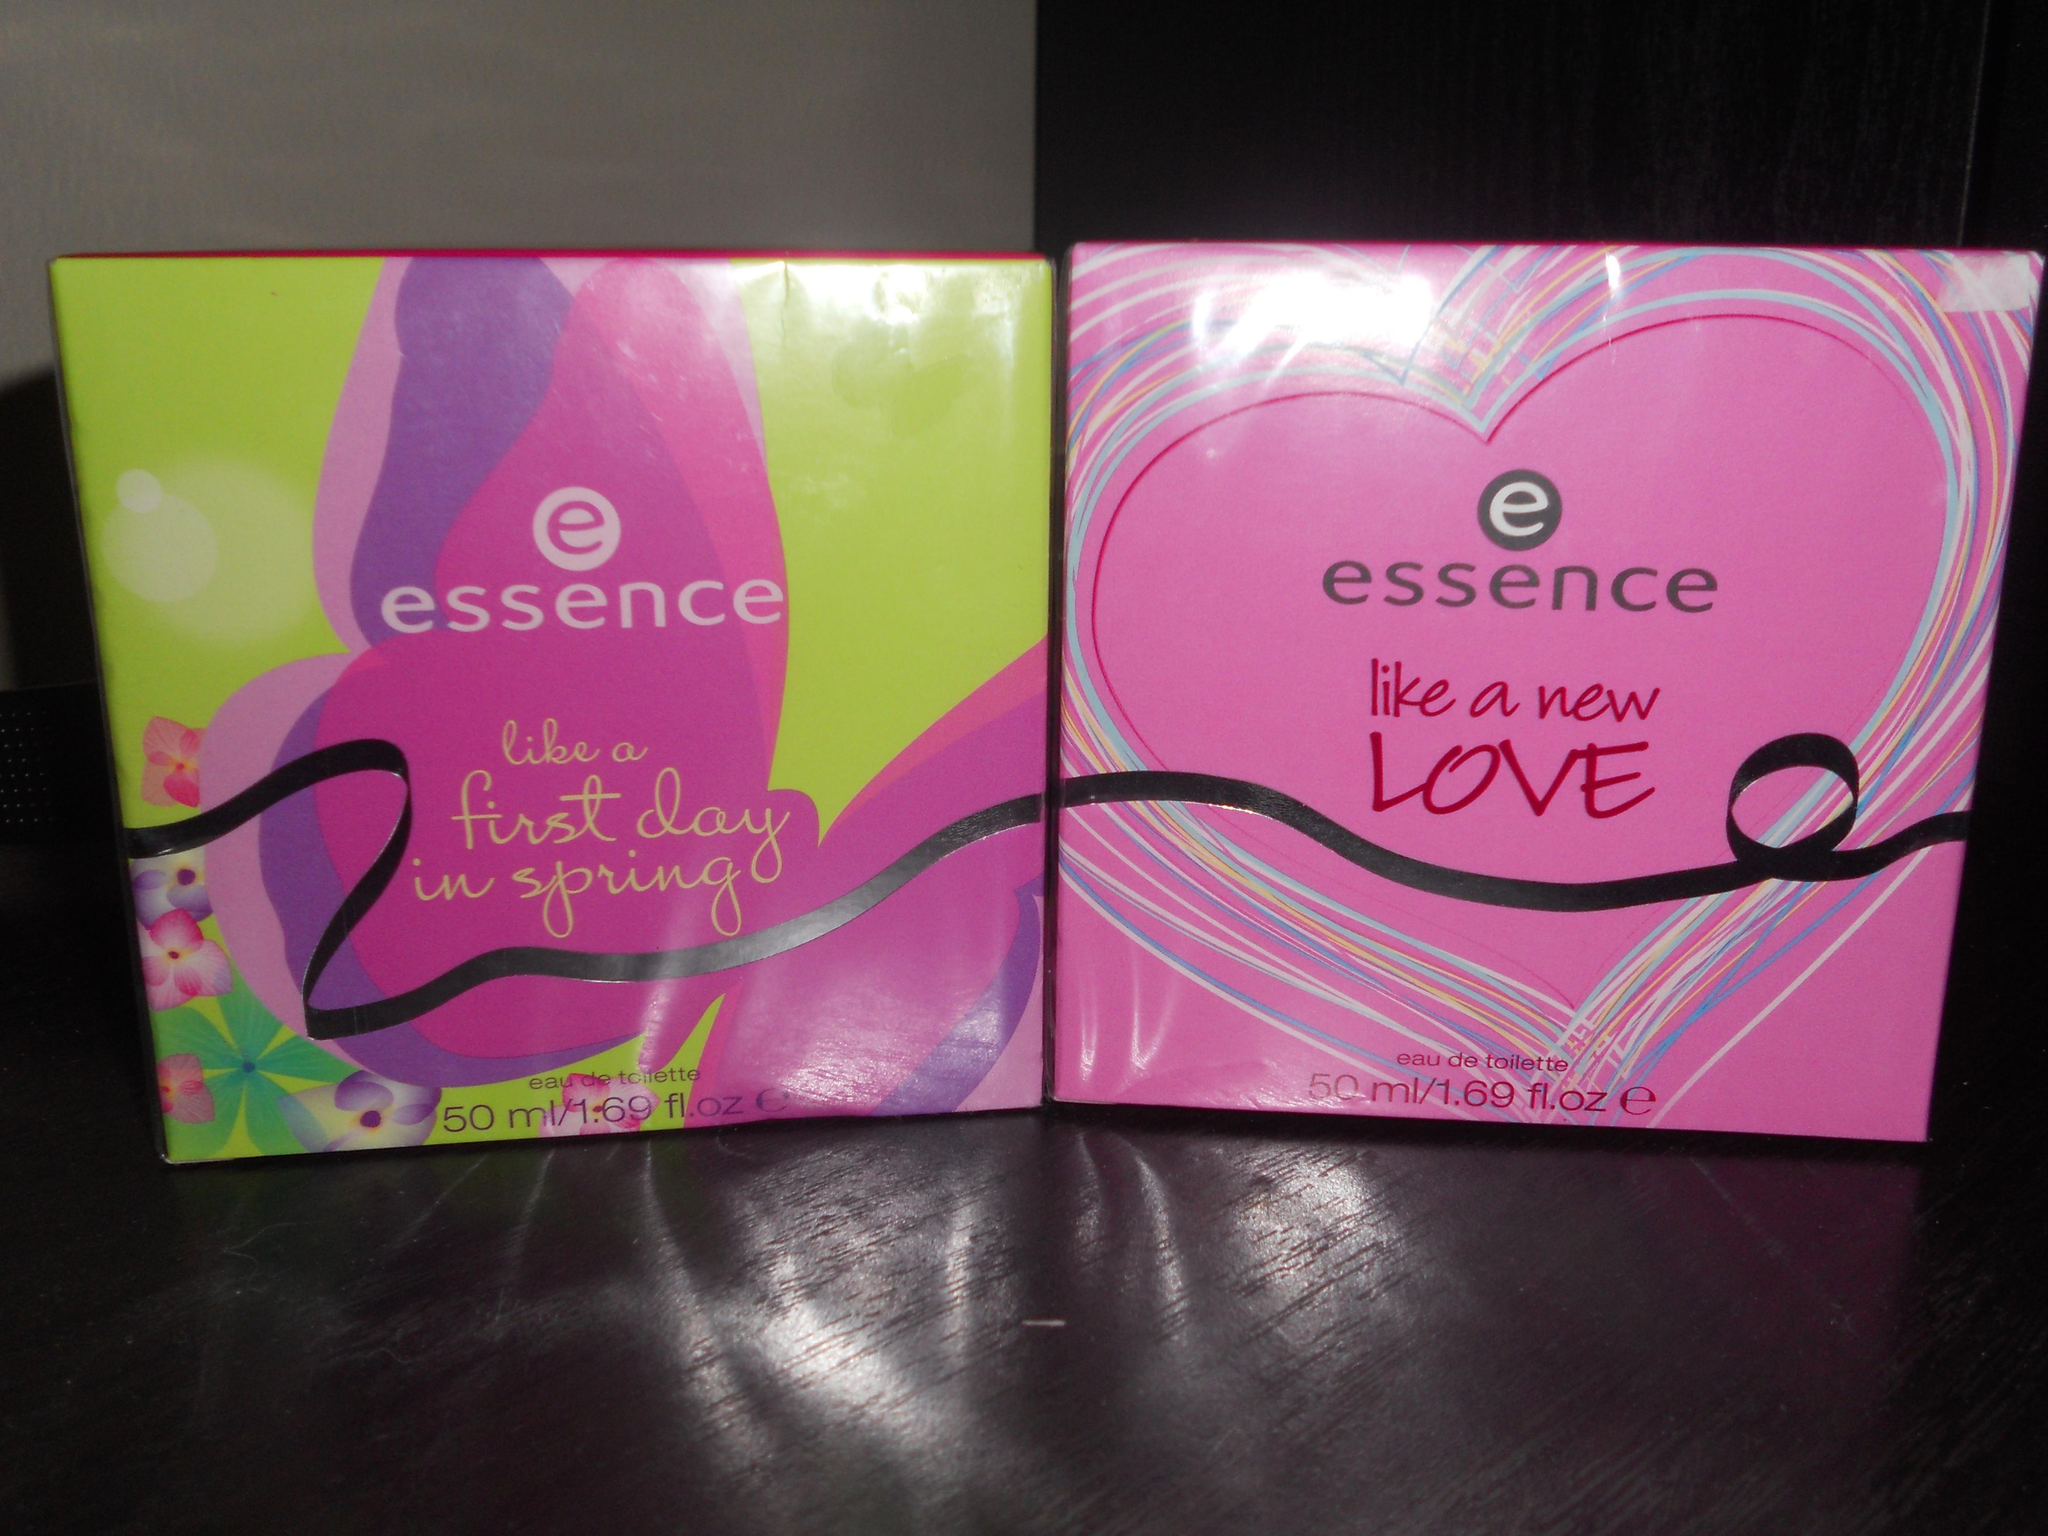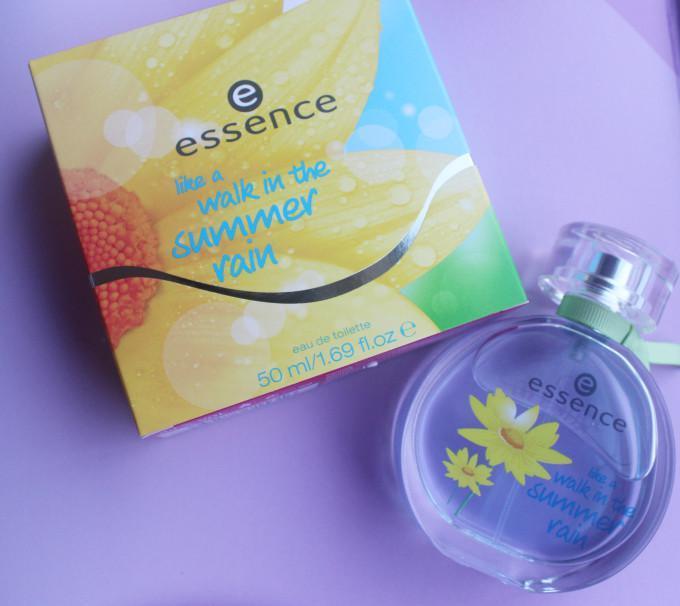The first image is the image on the left, the second image is the image on the right. Examine the images to the left and right. Is the description "The right image shows exactly one perfume in a circular bottle." accurate? Answer yes or no. Yes. 